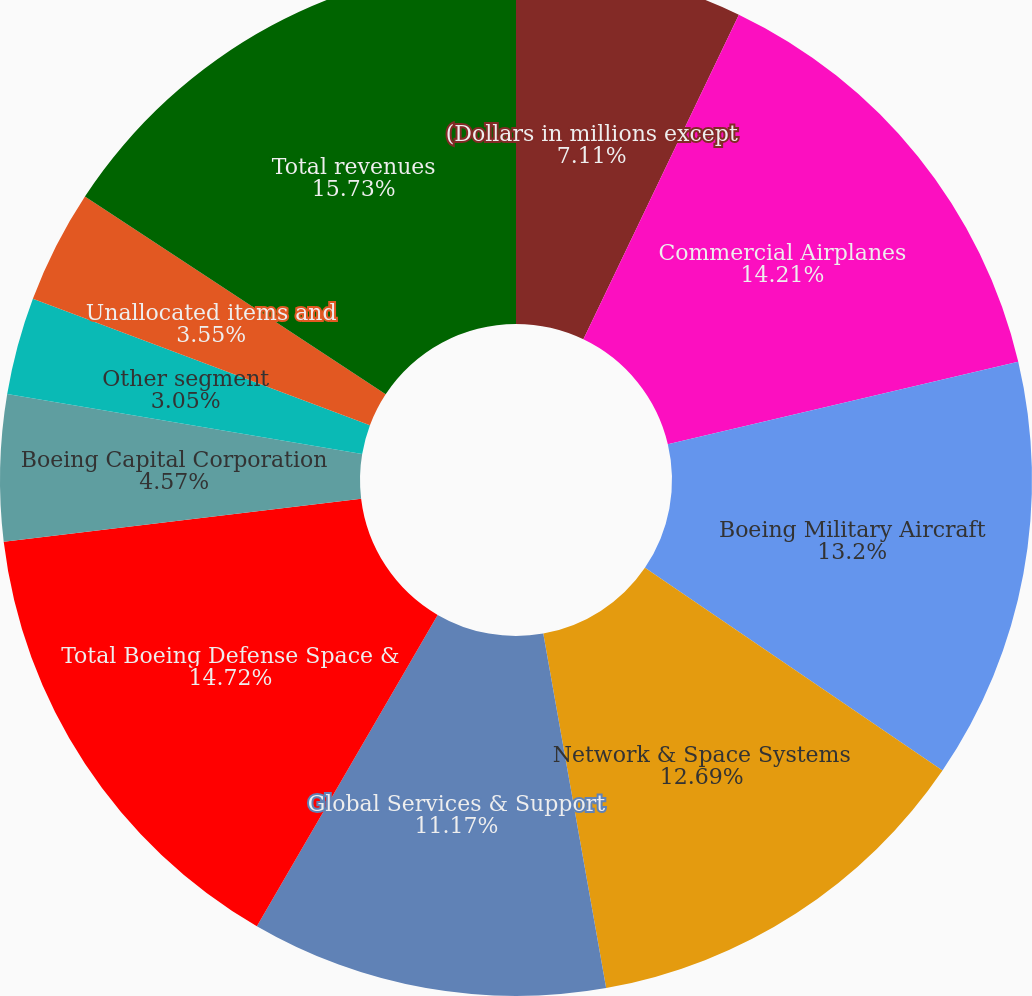<chart> <loc_0><loc_0><loc_500><loc_500><pie_chart><fcel>(Dollars in millions except<fcel>Commercial Airplanes<fcel>Boeing Military Aircraft<fcel>Network & Space Systems<fcel>Global Services & Support<fcel>Total Boeing Defense Space &<fcel>Boeing Capital Corporation<fcel>Other segment<fcel>Unallocated items and<fcel>Total revenues<nl><fcel>7.11%<fcel>14.21%<fcel>13.2%<fcel>12.69%<fcel>11.17%<fcel>14.72%<fcel>4.57%<fcel>3.05%<fcel>3.55%<fcel>15.74%<nl></chart> 